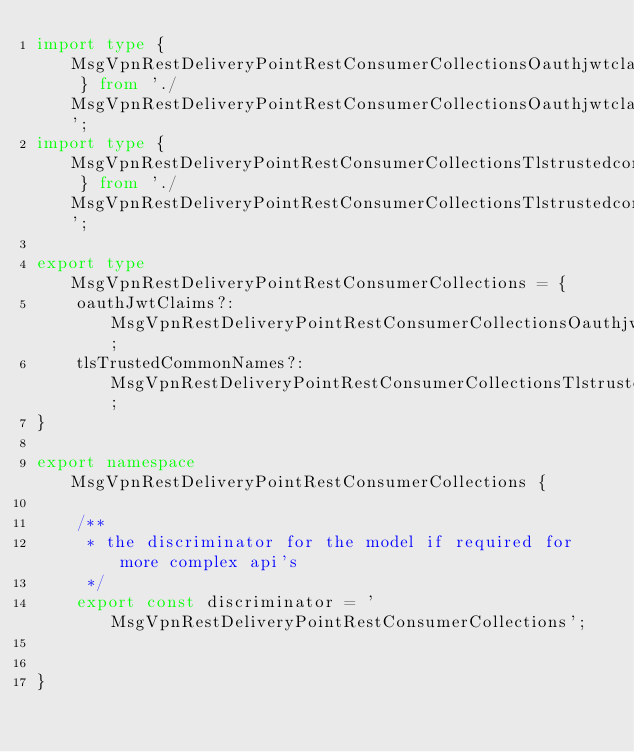<code> <loc_0><loc_0><loc_500><loc_500><_TypeScript_>import type { MsgVpnRestDeliveryPointRestConsumerCollectionsOauthjwtclaims } from './MsgVpnRestDeliveryPointRestConsumerCollectionsOauthjwtclaims';
import type { MsgVpnRestDeliveryPointRestConsumerCollectionsTlstrustedcommonnames } from './MsgVpnRestDeliveryPointRestConsumerCollectionsTlstrustedcommonnames';

export type MsgVpnRestDeliveryPointRestConsumerCollections = {
    oauthJwtClaims?: MsgVpnRestDeliveryPointRestConsumerCollectionsOauthjwtclaims;
    tlsTrustedCommonNames?: MsgVpnRestDeliveryPointRestConsumerCollectionsTlstrustedcommonnames;
}

export namespace MsgVpnRestDeliveryPointRestConsumerCollections {

    /**
     * the discriminator for the model if required for more complex api's
     */
    export const discriminator = 'MsgVpnRestDeliveryPointRestConsumerCollections';


}</code> 